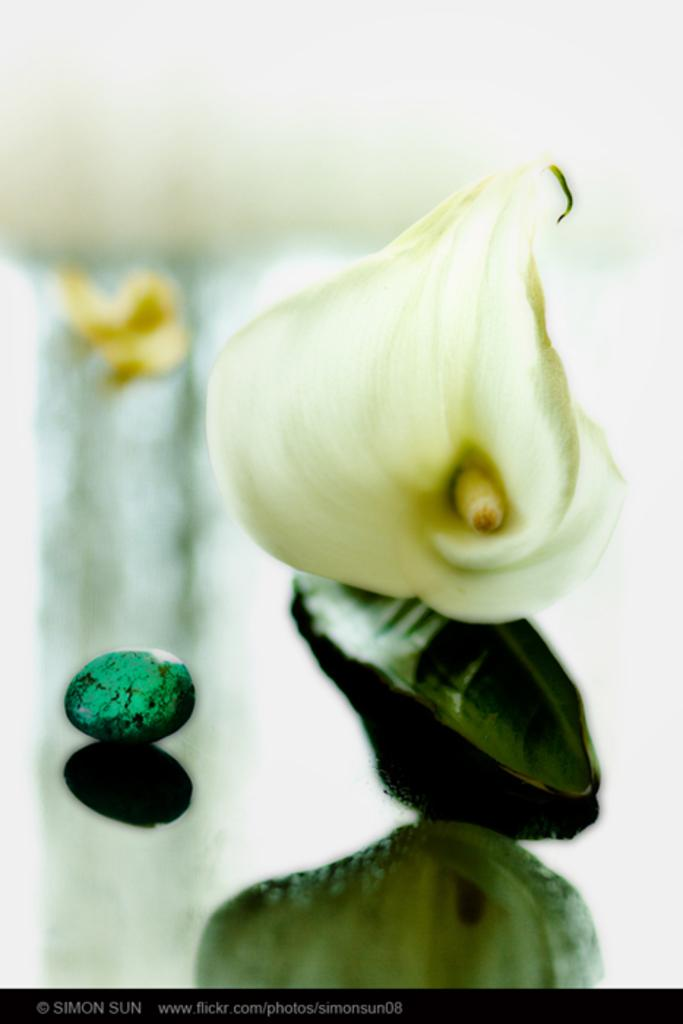What is located in the foreground of the image? There is a flower and a small stone in the foreground of the image. What type of surface is visible at the bottom of the image? There is a floor visible at the bottom of the image. What type of veil can be seen covering the flower in the image? There is no veil present in the image; the flower is not covered. 